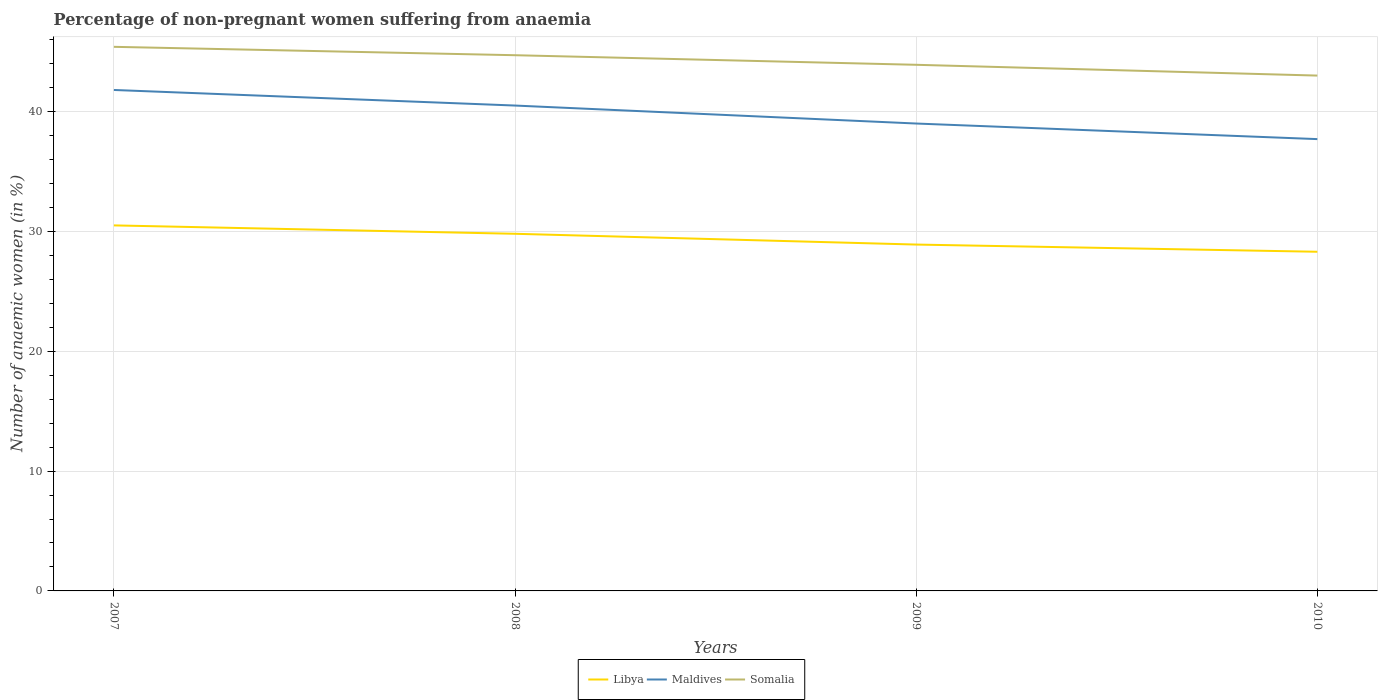How many different coloured lines are there?
Your answer should be very brief. 3. Is the number of lines equal to the number of legend labels?
Ensure brevity in your answer.  Yes. Across all years, what is the maximum percentage of non-pregnant women suffering from anaemia in Libya?
Provide a short and direct response. 28.3. What is the total percentage of non-pregnant women suffering from anaemia in Libya in the graph?
Provide a short and direct response. 1.6. What is the difference between the highest and the second highest percentage of non-pregnant women suffering from anaemia in Somalia?
Offer a terse response. 2.4. What is the difference between the highest and the lowest percentage of non-pregnant women suffering from anaemia in Libya?
Give a very brief answer. 2. Is the percentage of non-pregnant women suffering from anaemia in Libya strictly greater than the percentage of non-pregnant women suffering from anaemia in Somalia over the years?
Your answer should be compact. Yes. How many lines are there?
Keep it short and to the point. 3. How many years are there in the graph?
Give a very brief answer. 4. What is the difference between two consecutive major ticks on the Y-axis?
Give a very brief answer. 10. Does the graph contain any zero values?
Your answer should be compact. No. How many legend labels are there?
Ensure brevity in your answer.  3. What is the title of the graph?
Your answer should be very brief. Percentage of non-pregnant women suffering from anaemia. What is the label or title of the Y-axis?
Your response must be concise. Number of anaemic women (in %). What is the Number of anaemic women (in %) in Libya in 2007?
Your answer should be very brief. 30.5. What is the Number of anaemic women (in %) in Maldives in 2007?
Make the answer very short. 41.8. What is the Number of anaemic women (in %) of Somalia in 2007?
Ensure brevity in your answer.  45.4. What is the Number of anaemic women (in %) of Libya in 2008?
Ensure brevity in your answer.  29.8. What is the Number of anaemic women (in %) of Maldives in 2008?
Ensure brevity in your answer.  40.5. What is the Number of anaemic women (in %) in Somalia in 2008?
Your answer should be compact. 44.7. What is the Number of anaemic women (in %) in Libya in 2009?
Provide a succinct answer. 28.9. What is the Number of anaemic women (in %) in Somalia in 2009?
Ensure brevity in your answer.  43.9. What is the Number of anaemic women (in %) in Libya in 2010?
Keep it short and to the point. 28.3. What is the Number of anaemic women (in %) of Maldives in 2010?
Provide a succinct answer. 37.7. Across all years, what is the maximum Number of anaemic women (in %) of Libya?
Your answer should be very brief. 30.5. Across all years, what is the maximum Number of anaemic women (in %) of Maldives?
Your answer should be very brief. 41.8. Across all years, what is the maximum Number of anaemic women (in %) of Somalia?
Provide a succinct answer. 45.4. Across all years, what is the minimum Number of anaemic women (in %) of Libya?
Offer a very short reply. 28.3. Across all years, what is the minimum Number of anaemic women (in %) in Maldives?
Your answer should be compact. 37.7. Across all years, what is the minimum Number of anaemic women (in %) in Somalia?
Keep it short and to the point. 43. What is the total Number of anaemic women (in %) of Libya in the graph?
Offer a very short reply. 117.5. What is the total Number of anaemic women (in %) of Maldives in the graph?
Provide a short and direct response. 159. What is the total Number of anaemic women (in %) in Somalia in the graph?
Ensure brevity in your answer.  177. What is the difference between the Number of anaemic women (in %) in Libya in 2007 and that in 2008?
Offer a terse response. 0.7. What is the difference between the Number of anaemic women (in %) in Maldives in 2007 and that in 2008?
Provide a succinct answer. 1.3. What is the difference between the Number of anaemic women (in %) in Somalia in 2007 and that in 2008?
Offer a terse response. 0.7. What is the difference between the Number of anaemic women (in %) of Maldives in 2007 and that in 2009?
Your answer should be compact. 2.8. What is the difference between the Number of anaemic women (in %) in Somalia in 2007 and that in 2009?
Ensure brevity in your answer.  1.5. What is the difference between the Number of anaemic women (in %) in Libya in 2007 and that in 2010?
Give a very brief answer. 2.2. What is the difference between the Number of anaemic women (in %) in Maldives in 2007 and that in 2010?
Offer a very short reply. 4.1. What is the difference between the Number of anaemic women (in %) in Somalia in 2007 and that in 2010?
Your answer should be very brief. 2.4. What is the difference between the Number of anaemic women (in %) in Maldives in 2008 and that in 2009?
Your answer should be very brief. 1.5. What is the difference between the Number of anaemic women (in %) in Somalia in 2008 and that in 2009?
Your answer should be compact. 0.8. What is the difference between the Number of anaemic women (in %) of Somalia in 2008 and that in 2010?
Your response must be concise. 1.7. What is the difference between the Number of anaemic women (in %) of Libya in 2009 and that in 2010?
Give a very brief answer. 0.6. What is the difference between the Number of anaemic women (in %) of Libya in 2007 and the Number of anaemic women (in %) of Somalia in 2008?
Offer a very short reply. -14.2. What is the difference between the Number of anaemic women (in %) of Libya in 2007 and the Number of anaemic women (in %) of Maldives in 2009?
Offer a very short reply. -8.5. What is the difference between the Number of anaemic women (in %) of Libya in 2007 and the Number of anaemic women (in %) of Somalia in 2010?
Offer a very short reply. -12.5. What is the difference between the Number of anaemic women (in %) in Maldives in 2007 and the Number of anaemic women (in %) in Somalia in 2010?
Your answer should be very brief. -1.2. What is the difference between the Number of anaemic women (in %) in Libya in 2008 and the Number of anaemic women (in %) in Maldives in 2009?
Your answer should be very brief. -9.2. What is the difference between the Number of anaemic women (in %) of Libya in 2008 and the Number of anaemic women (in %) of Somalia in 2009?
Your response must be concise. -14.1. What is the difference between the Number of anaemic women (in %) of Libya in 2009 and the Number of anaemic women (in %) of Somalia in 2010?
Offer a very short reply. -14.1. What is the average Number of anaemic women (in %) in Libya per year?
Provide a short and direct response. 29.38. What is the average Number of anaemic women (in %) of Maldives per year?
Ensure brevity in your answer.  39.75. What is the average Number of anaemic women (in %) of Somalia per year?
Ensure brevity in your answer.  44.25. In the year 2007, what is the difference between the Number of anaemic women (in %) in Libya and Number of anaemic women (in %) in Somalia?
Provide a succinct answer. -14.9. In the year 2008, what is the difference between the Number of anaemic women (in %) of Libya and Number of anaemic women (in %) of Somalia?
Give a very brief answer. -14.9. In the year 2008, what is the difference between the Number of anaemic women (in %) of Maldives and Number of anaemic women (in %) of Somalia?
Offer a very short reply. -4.2. In the year 2009, what is the difference between the Number of anaemic women (in %) of Libya and Number of anaemic women (in %) of Maldives?
Keep it short and to the point. -10.1. In the year 2009, what is the difference between the Number of anaemic women (in %) in Maldives and Number of anaemic women (in %) in Somalia?
Provide a short and direct response. -4.9. In the year 2010, what is the difference between the Number of anaemic women (in %) of Libya and Number of anaemic women (in %) of Maldives?
Offer a terse response. -9.4. In the year 2010, what is the difference between the Number of anaemic women (in %) of Libya and Number of anaemic women (in %) of Somalia?
Provide a short and direct response. -14.7. In the year 2010, what is the difference between the Number of anaemic women (in %) of Maldives and Number of anaemic women (in %) of Somalia?
Make the answer very short. -5.3. What is the ratio of the Number of anaemic women (in %) in Libya in 2007 to that in 2008?
Provide a short and direct response. 1.02. What is the ratio of the Number of anaemic women (in %) of Maldives in 2007 to that in 2008?
Keep it short and to the point. 1.03. What is the ratio of the Number of anaemic women (in %) of Somalia in 2007 to that in 2008?
Provide a succinct answer. 1.02. What is the ratio of the Number of anaemic women (in %) of Libya in 2007 to that in 2009?
Give a very brief answer. 1.06. What is the ratio of the Number of anaemic women (in %) of Maldives in 2007 to that in 2009?
Provide a succinct answer. 1.07. What is the ratio of the Number of anaemic women (in %) of Somalia in 2007 to that in 2009?
Your response must be concise. 1.03. What is the ratio of the Number of anaemic women (in %) in Libya in 2007 to that in 2010?
Offer a very short reply. 1.08. What is the ratio of the Number of anaemic women (in %) in Maldives in 2007 to that in 2010?
Offer a terse response. 1.11. What is the ratio of the Number of anaemic women (in %) in Somalia in 2007 to that in 2010?
Give a very brief answer. 1.06. What is the ratio of the Number of anaemic women (in %) of Libya in 2008 to that in 2009?
Offer a terse response. 1.03. What is the ratio of the Number of anaemic women (in %) of Maldives in 2008 to that in 2009?
Offer a very short reply. 1.04. What is the ratio of the Number of anaemic women (in %) in Somalia in 2008 to that in 2009?
Offer a very short reply. 1.02. What is the ratio of the Number of anaemic women (in %) of Libya in 2008 to that in 2010?
Your answer should be compact. 1.05. What is the ratio of the Number of anaemic women (in %) of Maldives in 2008 to that in 2010?
Provide a short and direct response. 1.07. What is the ratio of the Number of anaemic women (in %) in Somalia in 2008 to that in 2010?
Provide a succinct answer. 1.04. What is the ratio of the Number of anaemic women (in %) of Libya in 2009 to that in 2010?
Your answer should be very brief. 1.02. What is the ratio of the Number of anaemic women (in %) in Maldives in 2009 to that in 2010?
Your response must be concise. 1.03. What is the ratio of the Number of anaemic women (in %) of Somalia in 2009 to that in 2010?
Offer a terse response. 1.02. What is the difference between the highest and the second highest Number of anaemic women (in %) of Maldives?
Offer a terse response. 1.3. What is the difference between the highest and the second highest Number of anaemic women (in %) of Somalia?
Make the answer very short. 0.7. What is the difference between the highest and the lowest Number of anaemic women (in %) of Maldives?
Give a very brief answer. 4.1. What is the difference between the highest and the lowest Number of anaemic women (in %) in Somalia?
Provide a succinct answer. 2.4. 